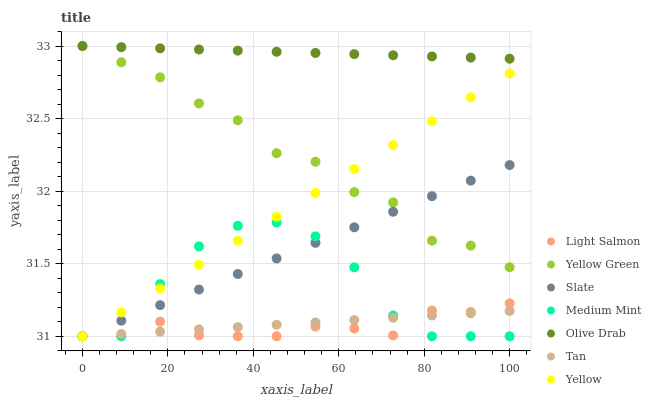Does Light Salmon have the minimum area under the curve?
Answer yes or no. Yes. Does Olive Drab have the maximum area under the curve?
Answer yes or no. Yes. Does Yellow Green have the minimum area under the curve?
Answer yes or no. No. Does Yellow Green have the maximum area under the curve?
Answer yes or no. No. Is Olive Drab the smoothest?
Answer yes or no. Yes. Is Medium Mint the roughest?
Answer yes or no. Yes. Is Light Salmon the smoothest?
Answer yes or no. No. Is Light Salmon the roughest?
Answer yes or no. No. Does Medium Mint have the lowest value?
Answer yes or no. Yes. Does Yellow Green have the lowest value?
Answer yes or no. No. Does Olive Drab have the highest value?
Answer yes or no. Yes. Does Light Salmon have the highest value?
Answer yes or no. No. Is Medium Mint less than Olive Drab?
Answer yes or no. Yes. Is Olive Drab greater than Yellow?
Answer yes or no. Yes. Does Light Salmon intersect Medium Mint?
Answer yes or no. Yes. Is Light Salmon less than Medium Mint?
Answer yes or no. No. Is Light Salmon greater than Medium Mint?
Answer yes or no. No. Does Medium Mint intersect Olive Drab?
Answer yes or no. No. 